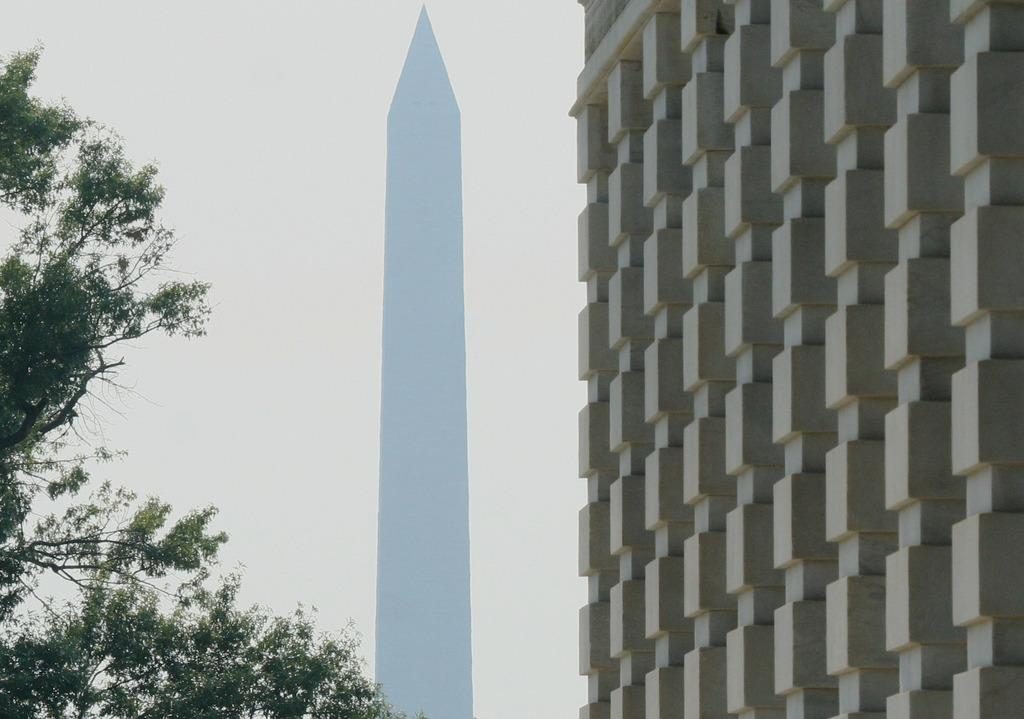What type of structure is present in the image? There is a building in the image. What other feature can be seen in the image? There is a tower in the image. What type of vegetation is visible in the image? There are trees in the image. What is visible in the background of the image? The sky is visible in the background of the image. Can you see a goat swimming in the sky in the image? No, there is no goat or swimming activity depicted in the image. The image features a building, a tower, trees, and the sky in the background. 